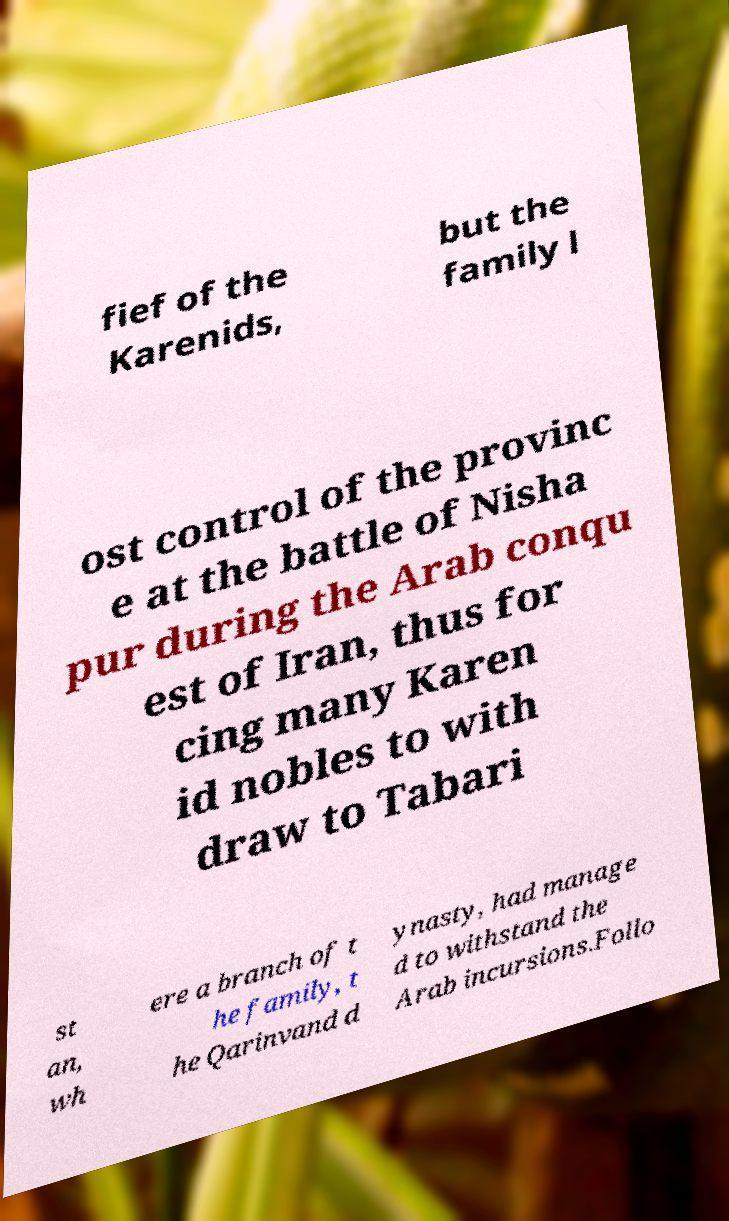Please identify and transcribe the text found in this image. fief of the Karenids, but the family l ost control of the provinc e at the battle of Nisha pur during the Arab conqu est of Iran, thus for cing many Karen id nobles to with draw to Tabari st an, wh ere a branch of t he family, t he Qarinvand d ynasty, had manage d to withstand the Arab incursions.Follo 